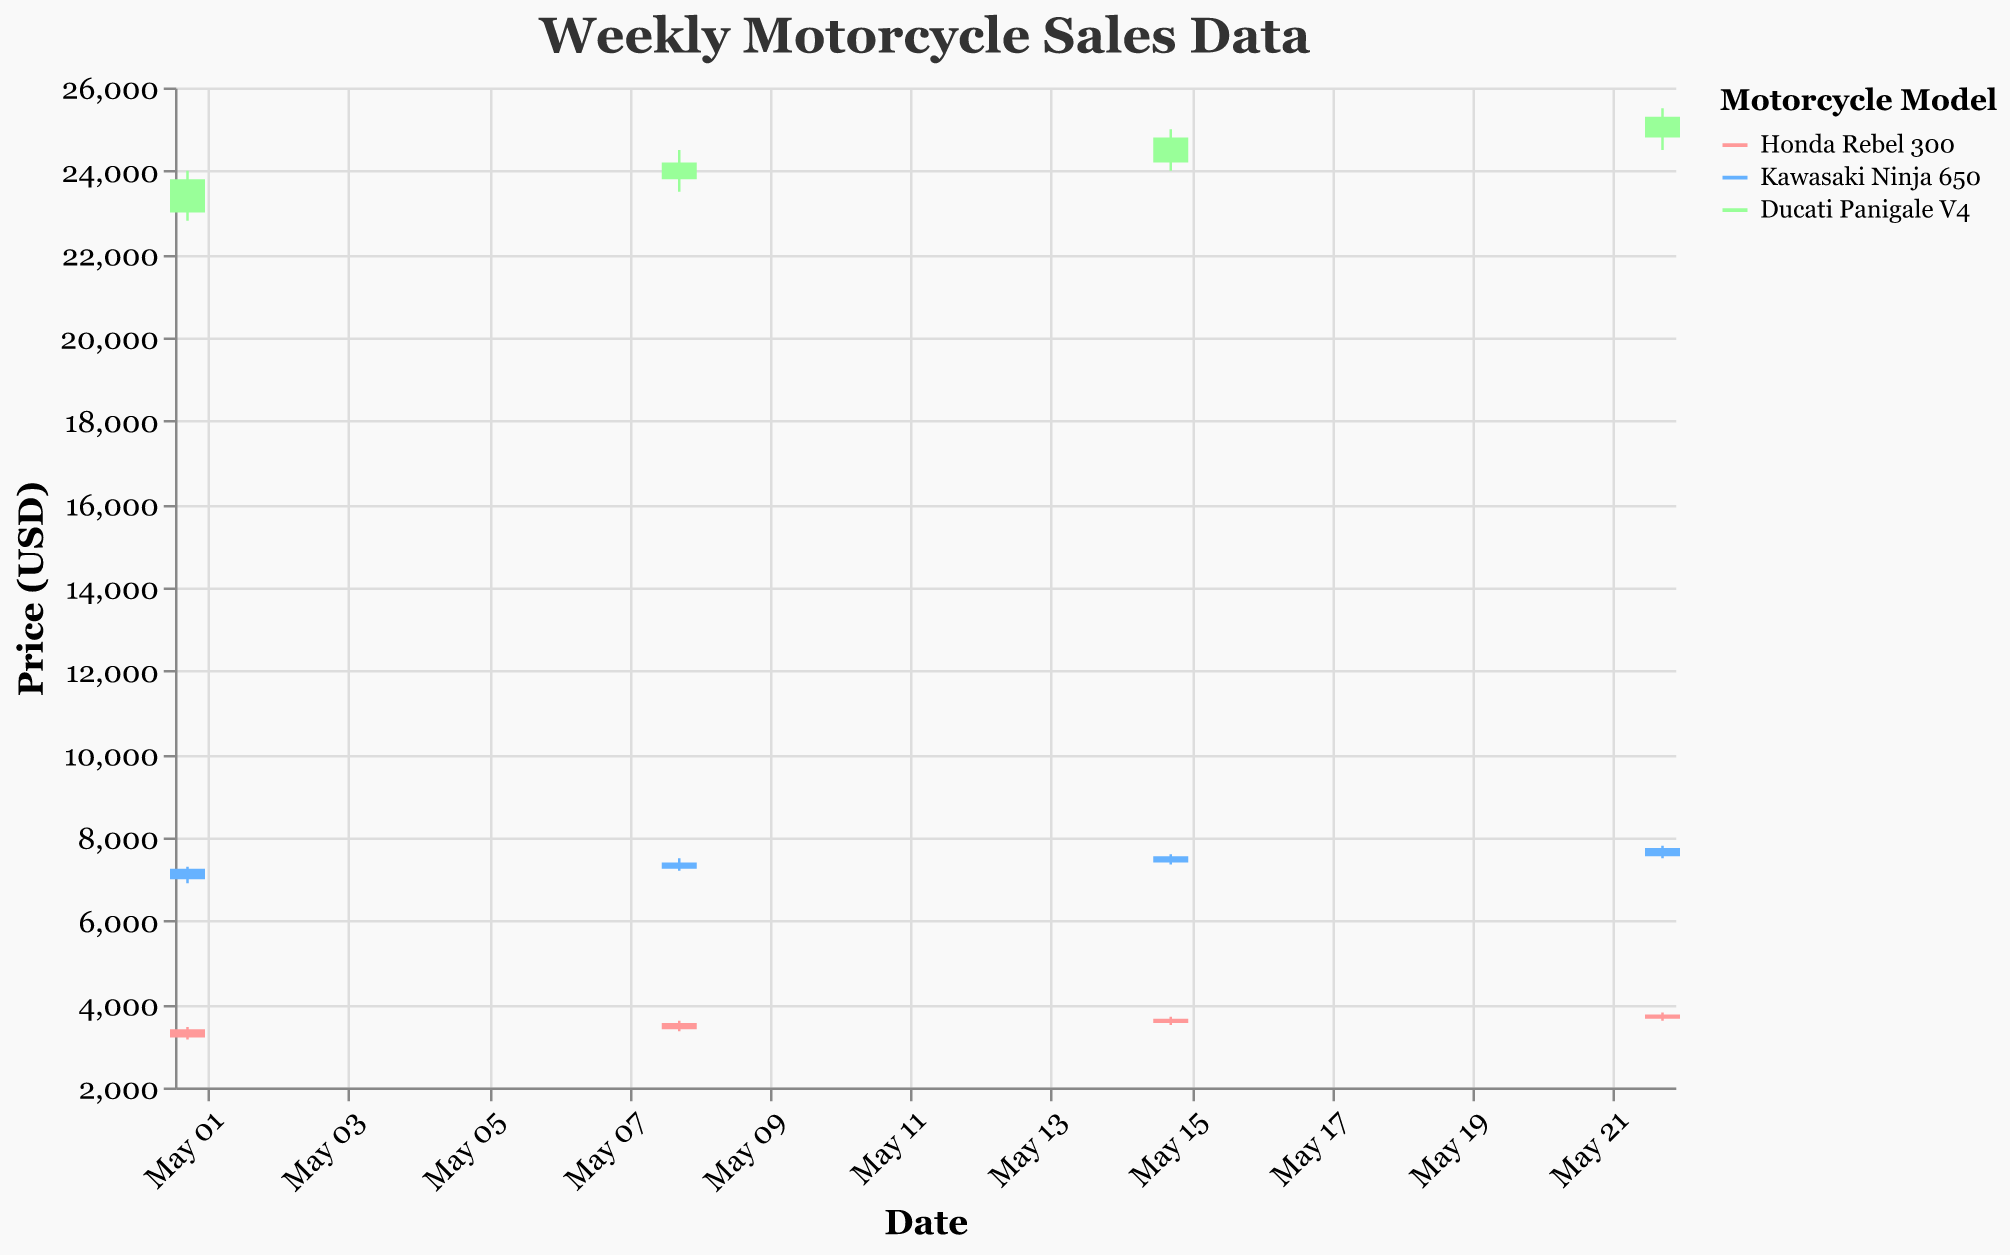What's the title of the figure? The title is displayed at the top of the figure and reads "Weekly Motorcycle Sales Data".
Answer: Weekly Motorcycle Sales Data How many motorcycle models are represented in the chart? By checking the legend or the colors used in the chart, we see three models: Honda Rebel 300, Kawasaki Ninja 650, and Ducati Panigale V4.
Answer: Three What's the closing price of the Ducati Panigale V4 on May 8, 2023? Look at the data point for the Ducati Panigale V4 on May 8, 2023, and identify the 'Close' value, which is 24,200 USD.
Answer: 24,200 USD Which motorcycle model has the highest closing price in the entire period? Compare the closing prices of all models over the entire timeline. Ducati Panigale V4 has the highest closing price on May 22, 2023, at 25,300 USD.
Answer: Ducati Panigale V4 Did the Kawasaki Ninja 650 have a consistently increasing closing price over the weeks? Examine the closing prices for Kawasaki Ninja 650 across all dates: 7,250 → 7,400 → 7,550 → 7,750 USD. Since the prices are consistently increasing, the answer is yes.
Answer: Yes What's the largest difference between the high and low prices for the Honda Rebel 300 within a week? Calculate the difference between High and Low prices for each week of Honda Rebel 300. For May 22, 2023, the difference is 3,800 - 3,600 = 200 USD, which is the largest difference.
Answer: 200 USD Which week had the highest opening price for Honda Rebel 300? Examine the opening prices for Honda Rebel 300 on different dates: May 1 (3,200), May 8 (3,400), May 15 (3,550), and May 22 (3,650). The highest opening price is on May 22, 2023.
Answer: May 22, 2023 How does the volatility (High-Low spread) of Ducati Panigale V4 compare across the four weeks? Calculate the difference between High and Low prices for Ducati Panigale V4 for each week: May 1 (1,200), May 8 (1,000), May 15 (1,000), May 22 (1,000). Only May 1 has a different volatility (1,200) while the rest are the same (1,000).
Answer: May 1 has higher volatility Did the closing price of the Honda Rebel 300 ever surpass the opening price of the Kawasaki Ninja 650? Compare the closing prices of Honda Rebel 300 with the opening prices of the Kawasaki Ninja 650 across all weeks. Yes, the closing price of Honda Rebel 300 on May 22 ($3,750) surpassed the opening price of Kawasaki Ninja 650 on May 1 ($7,000).
Answer: No What's the average closing price for Kawasaki Ninja 650 for the entire period? Sum the closing prices of Kawasaki Ninja 650 for all weeks (7,250 + 7,400 + 7,550 + 7,750 = 29,950) and divide by the number of weeks (4). The average is 29,950 / 4 = 7,487.5 USD.
Answer: 7,487.5 USD 